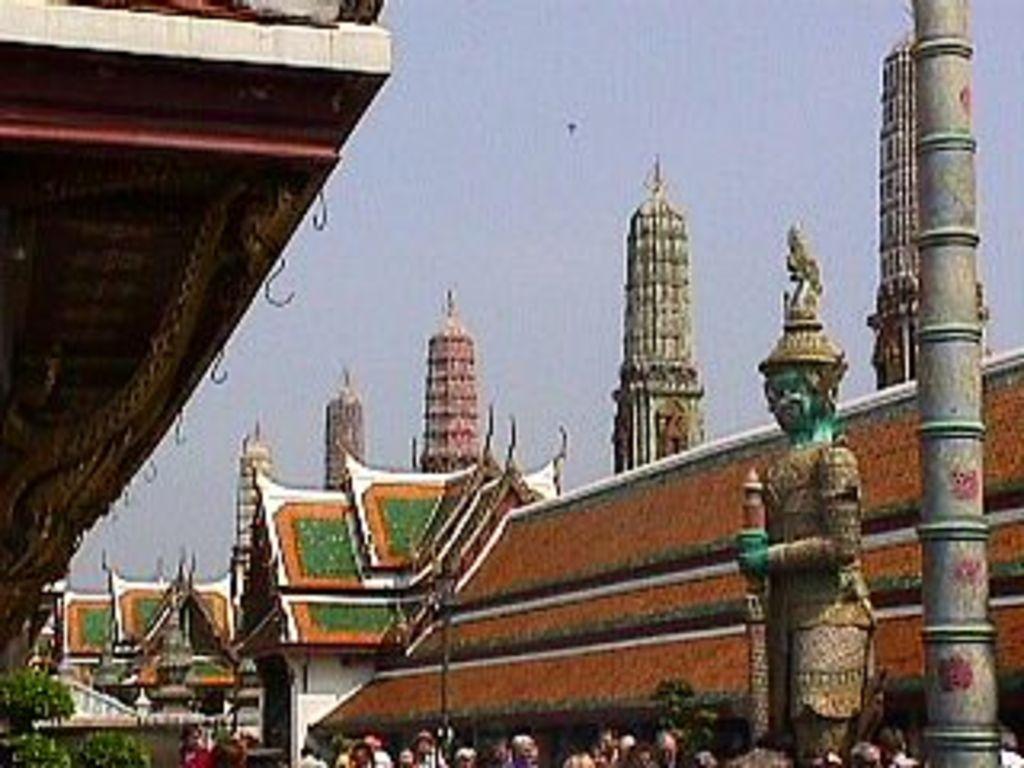Could you give a brief overview of what you see in this image? At the bottom of the image few people are standing and there is a statue. Behind the statue there are some buildings and poles. At the top of the image there is sky. 